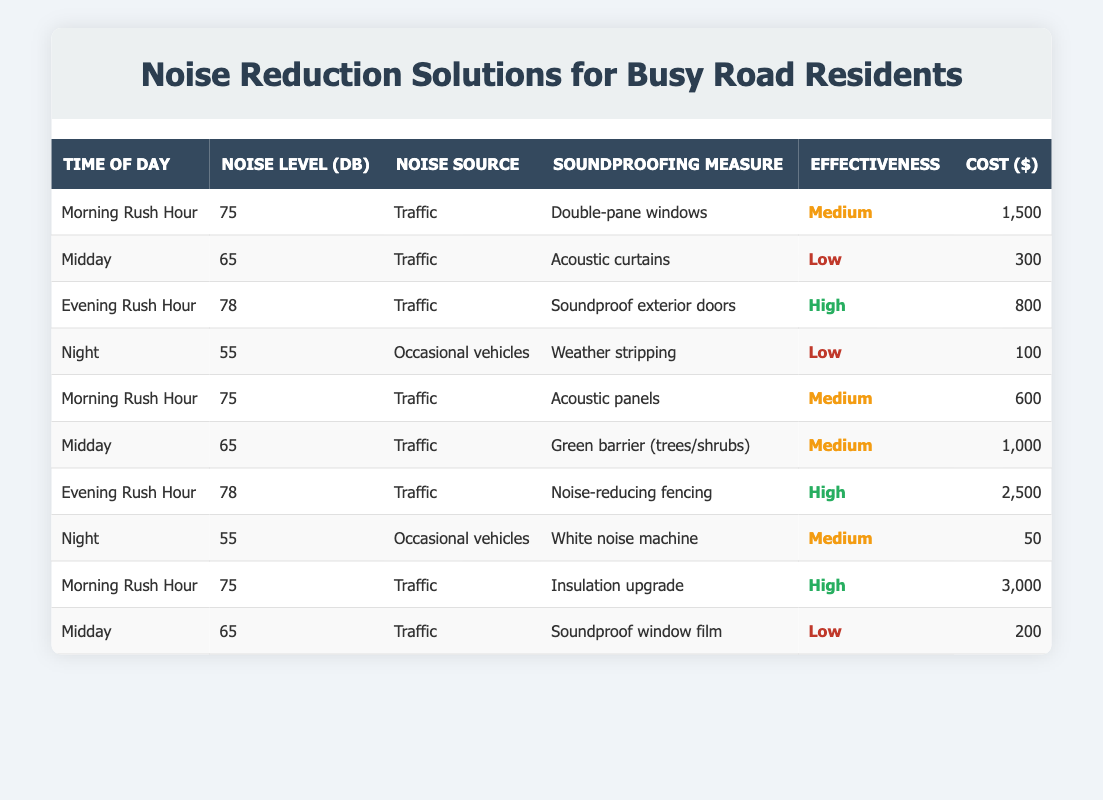What are the noise levels during the Evening Rush Hour? According to the table, the noise level during the Evening Rush Hour is 78 dB.
Answer: 78 dB Which soundproofing measure has the lowest cost? The table shows that the White Noise Machine has a cost of $50, which is the lowest among all measures listed.
Answer: $50 Is the effectiveness of Acoustic Curtains high? The table indicates that the effectiveness of Acoustic Curtains is rated as Low, so it is not high.
Answer: No What is the average cost of soundproofing measures in the Morning Rush Hour? There are three measures listed for the Morning Rush Hour with costs of $1,500 (Double-pane windows), $600 (Acoustic panels), and $3,000 (Insulation upgrade). The total cost is 1,500 + 600 + 3,000 = 5,100, and dividing by 3 gives an average of 5,100 / 3 = 1,700.
Answer: $1,700 How many soundproofing measures are rated as High in effectiveness? The data indicates that there are three soundproofing measures rated as High in effectiveness: Soundproof exterior doors, Noise-reducing fencing, and Insulation upgrade.
Answer: 3 Which time of day has the highest noise level listed? The table lists the highest noise level of 78 dB during the Evening Rush Hour. This is confirmed by comparing all listed noise levels across different times of day.
Answer: Evening Rush Hour What are the costs associated with soundproofing measures rated High in effectiveness? The soundproofing measures rated as High are Soundproof exterior doors ($800), Noise-reducing fencing ($2,500), and Insulation upgrade ($3,000). Adding these costs gives $800 + $2,500 + $3,000 = $6,300.
Answer: $6,300 Is there a soundproofing measure used at Night? The table lists two measures for the Night: Weather stripping and White noise machine, confirming that soundproofing measures are indeed used at this time.
Answer: Yes How does the noise level at Night compare to that during Midday? The table shows a noise level of 55 dB at Night and 65 dB at Midday. Hence, 55 dB (Night) is lower than 65 dB (Midday) by 10 dB.
Answer: 10 dB lower 